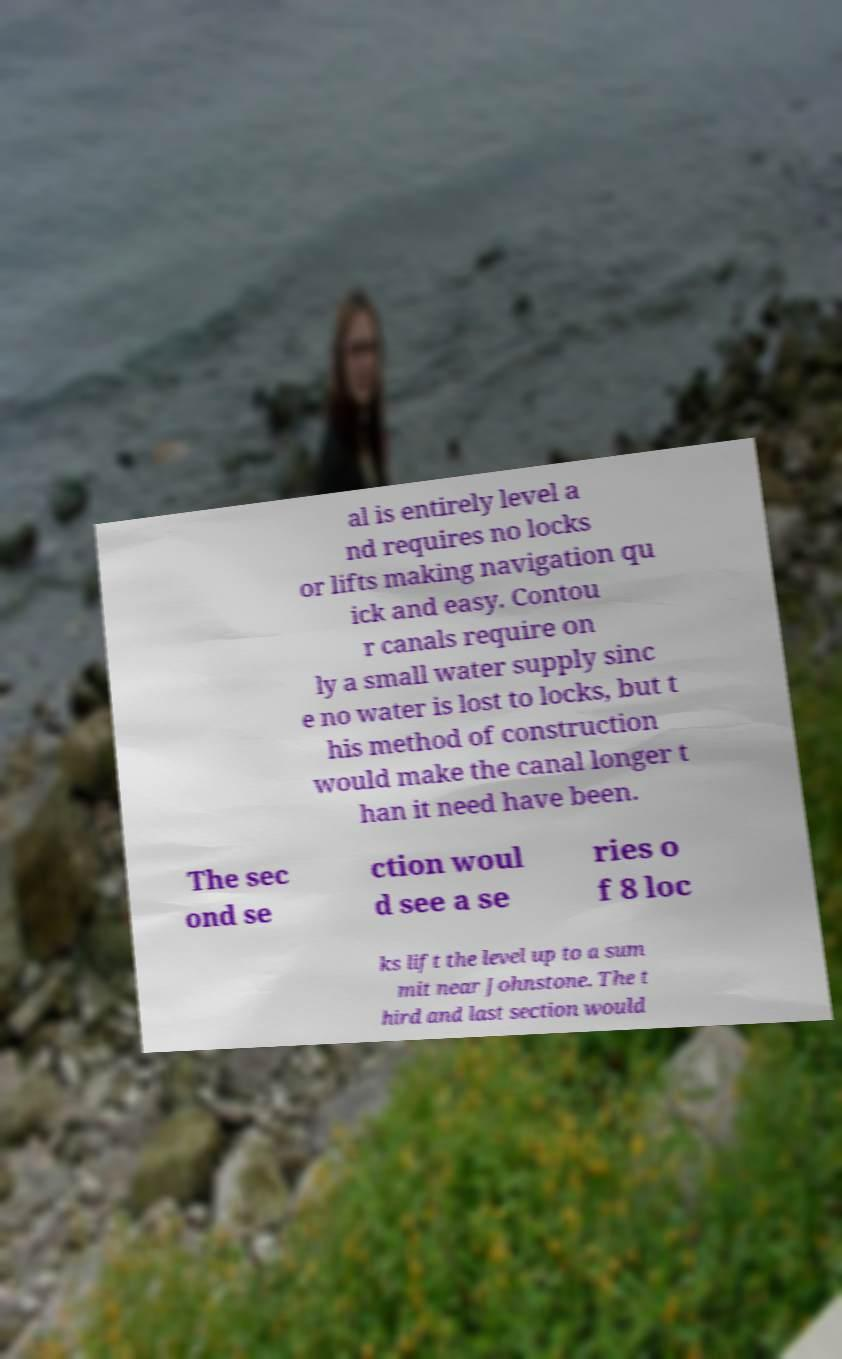For documentation purposes, I need the text within this image transcribed. Could you provide that? al is entirely level a nd requires no locks or lifts making navigation qu ick and easy. Contou r canals require on ly a small water supply sinc e no water is lost to locks, but t his method of construction would make the canal longer t han it need have been. The sec ond se ction woul d see a se ries o f 8 loc ks lift the level up to a sum mit near Johnstone. The t hird and last section would 